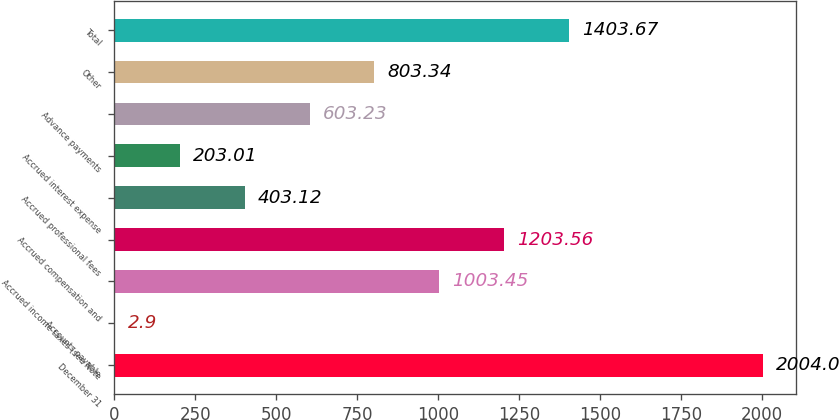Convert chart. <chart><loc_0><loc_0><loc_500><loc_500><bar_chart><fcel>December 31<fcel>Accounts payable<fcel>Accrued income taxes (see Note<fcel>Accrued compensation and<fcel>Accrued professional fees<fcel>Accrued interest expense<fcel>Advance payments<fcel>Other<fcel>Total<nl><fcel>2004<fcel>2.9<fcel>1003.45<fcel>1203.56<fcel>403.12<fcel>203.01<fcel>603.23<fcel>803.34<fcel>1403.67<nl></chart> 